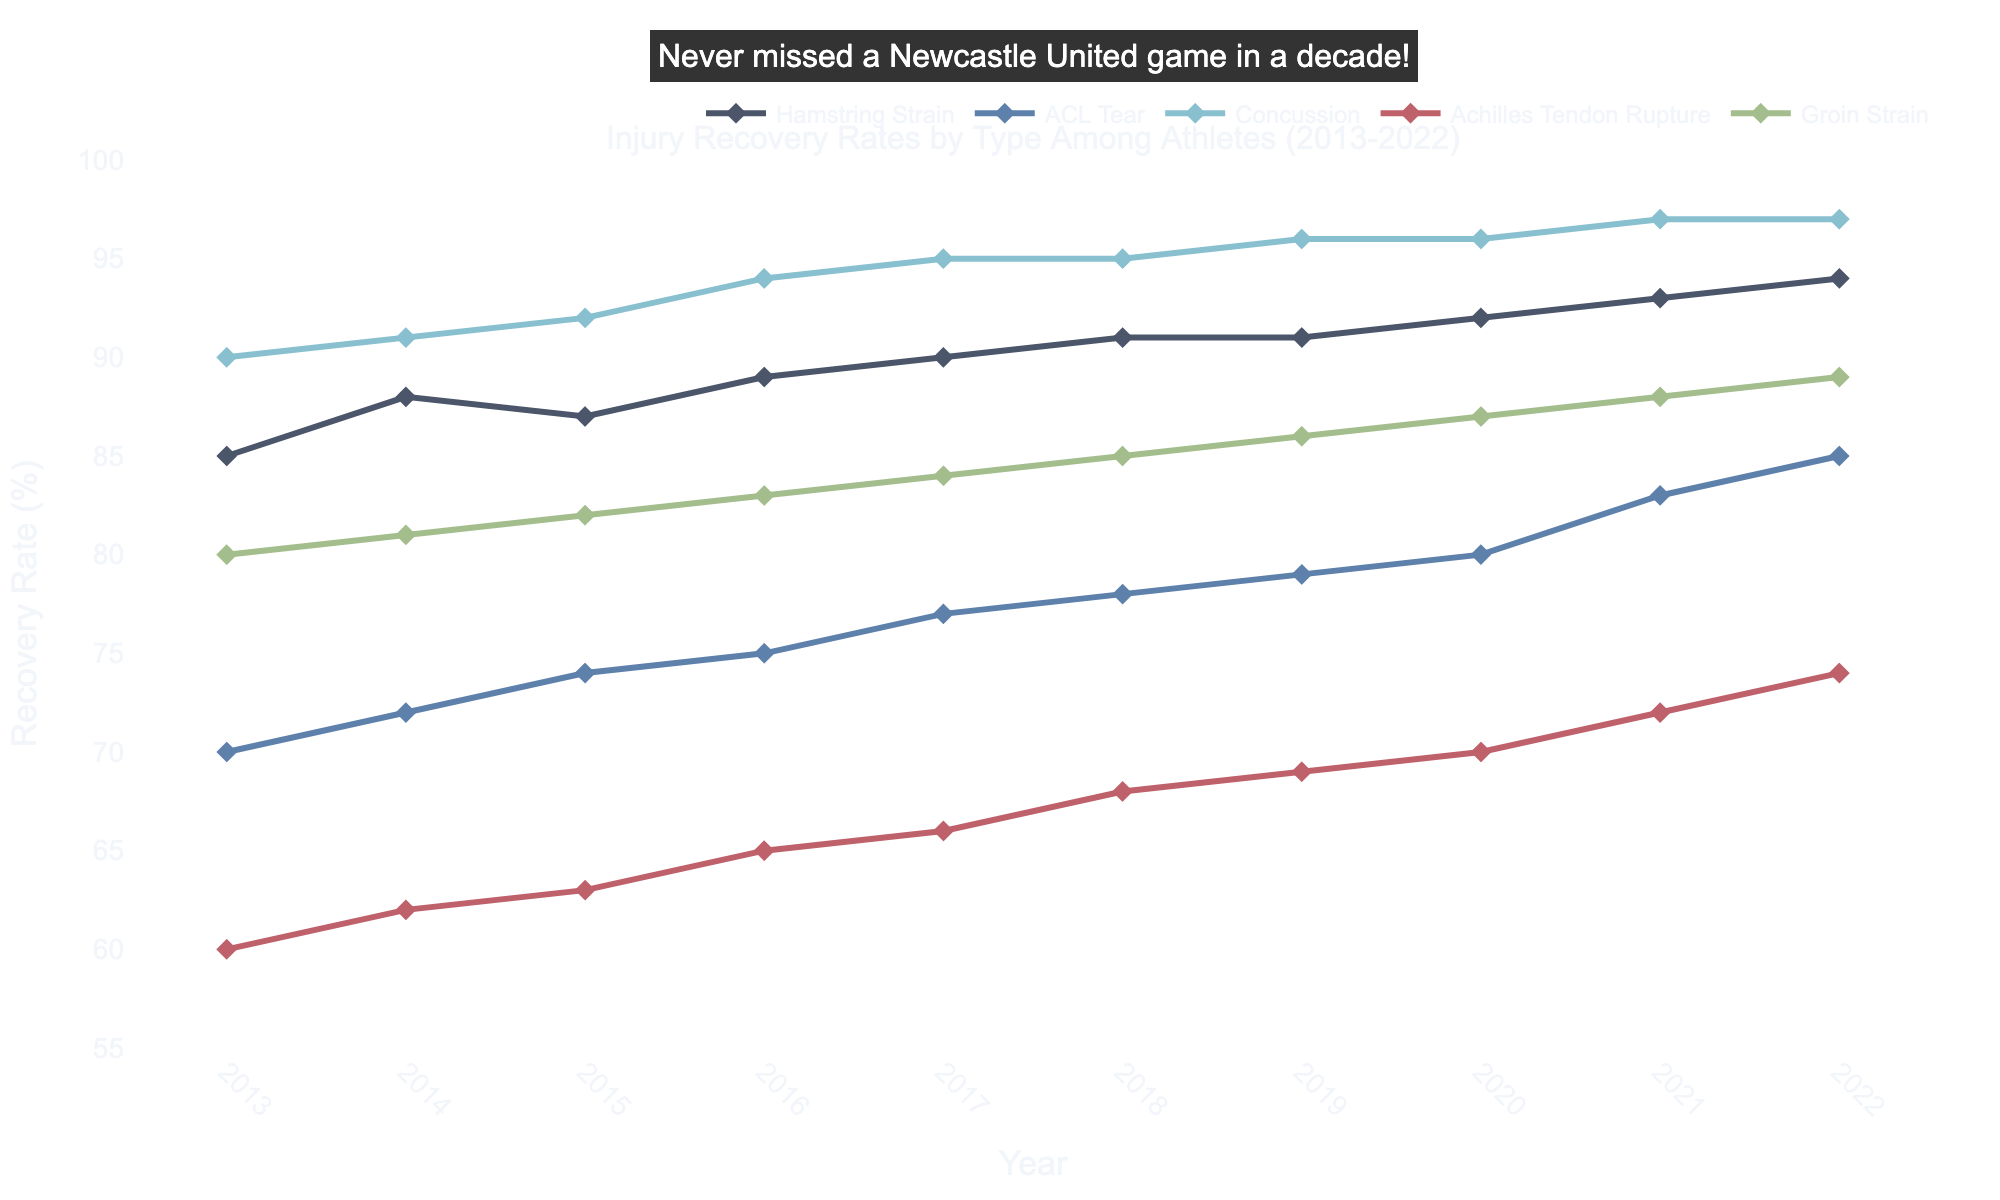What's the title of the plot? The title of the plot is typically located at the top center of the figure.
Answer: Injury Recovery Rates by Type Among Athletes (2013-2022) Which injury type had the highest recovery rate in 2022? By looking at the data points for the year 2022, we can compare the recovery rates for all types of injuries listed. The highest recovery rate corresponds to “Concussion” at 97%.
Answer: Concussion How many injury types are shown in the figure? By counting the different lines and their corresponding labels in the legend, we can determine the number of separate injury types represented. There are five distinct injury types shown.
Answer: 5 Which injury type has shown the most consistent improvement over the decade? By comparing the trends of each injury type from 2013 to 2022, we see that both “Hamstring Strain” and “Concussion” show consistent progress. To determine the most consistent, notice that "Concussion" has most consistently improved without any years of stagnation or minor decreases, unlike "Hamstring Strain."
Answer: Concussion What is the average recovery rate for ACL Tear between 2013 and 2022? Add the recovery rates for each year (70 + 72 + 74 + 75 + 77 + 78 + 79 + 80 + 83 + 85) and then divide by the number of years (10). 
(70+72+74+75+77+78+79+80+83+85) = 773, and 773/10 = 77.3.
Answer: 77.3 Which injury type had the biggest improvement in recovery rate from 2013 to 2022? Calculate the difference in recovery rate between the years 2013 and 2022 for each injury type and compare the values. "Achilles Tendon Rupture" improved from 60% to 74%, a total improvement of 14%.
Answer: Achilles Tendon Rupture What is the smallest recovery rate percentage recorded in any year for any injury type? Analyze all the data points on the y-axis to find the minimum value recorded. The smallest recovery rate percentage is 60% for "Achilles Tendon Rupture" in 2013.
Answer: 60% Which injury recovery rate exceeds 90% consistently after 2015? Identify the injury type whose recovery rates are consistently above 90% every year after 2015. "Concussion" recovery rate meets this criterion, remaining above 90% from 2016 onwards.
Answer: Concussion Which two injury types had a recovery rate of 91% in 2018? Locate the data points for the year 2018 and compare which lines/points intersect 91% on the y-axis. Both "Hamstring Strain" and “Concussion” had a recovery rate of 91%.
Answer: Hamstring Strain and Concussion How much did the recovery rate for Groin Strain improve from 2013 to 2022? Subtract the recovery rate of 2013 from that of 2022 for Groin Strain. The calculation is 89% (2022) - 80% (2013) = 9%.
Answer: 9% 